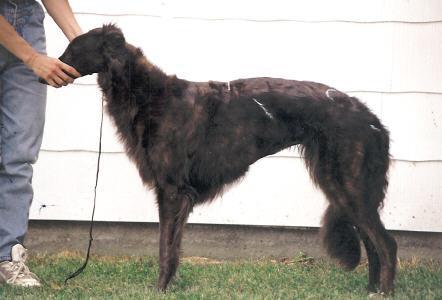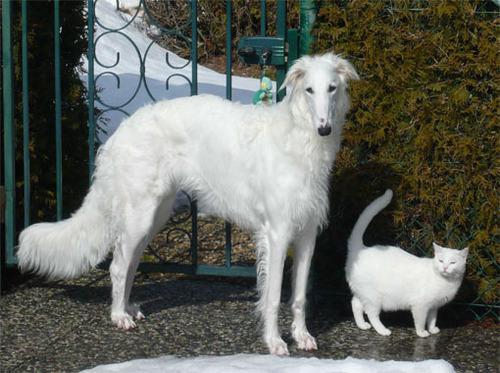The first image is the image on the left, the second image is the image on the right. Analyze the images presented: Is the assertion "The combined images include a person near a dog and a dog next to a horse." valid? Answer yes or no. No. The first image is the image on the left, the second image is the image on the right. Given the left and right images, does the statement "There is a horse and two dogs staring in the same direction" hold true? Answer yes or no. No. 